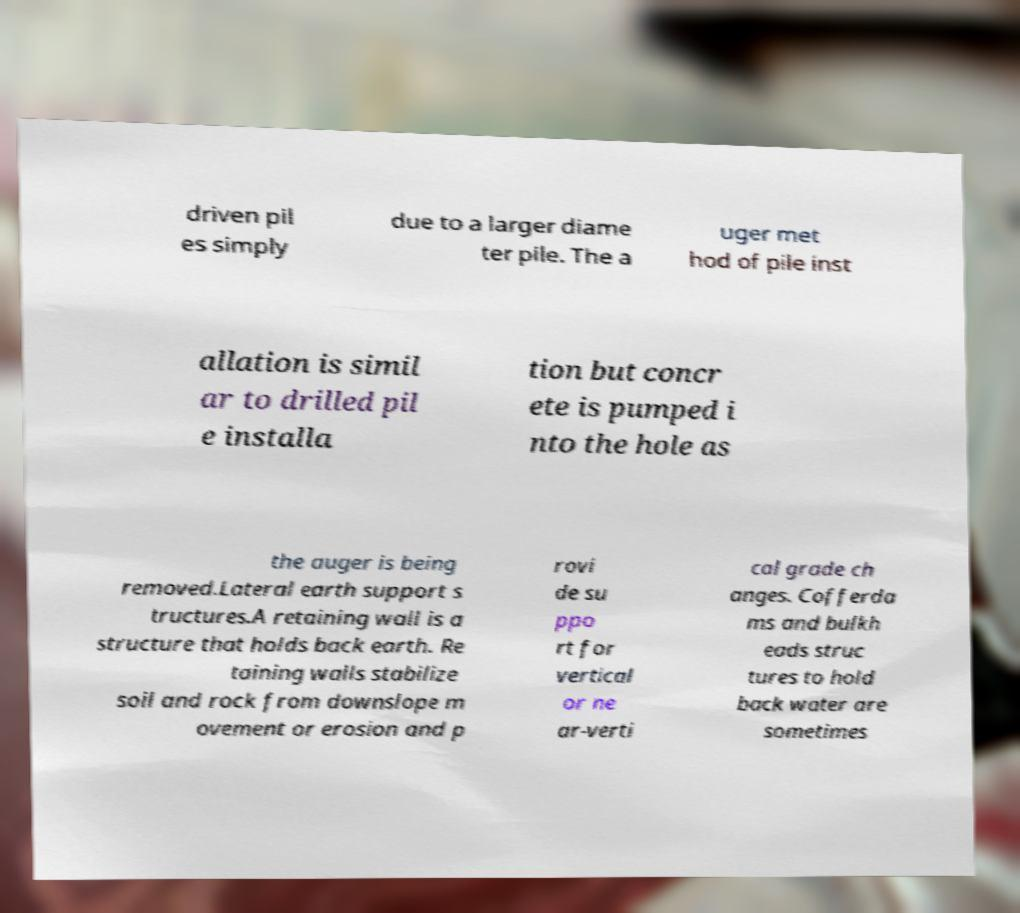What messages or text are displayed in this image? I need them in a readable, typed format. driven pil es simply due to a larger diame ter pile. The a uger met hod of pile inst allation is simil ar to drilled pil e installa tion but concr ete is pumped i nto the hole as the auger is being removed.Lateral earth support s tructures.A retaining wall is a structure that holds back earth. Re taining walls stabilize soil and rock from downslope m ovement or erosion and p rovi de su ppo rt for vertical or ne ar-verti cal grade ch anges. Cofferda ms and bulkh eads struc tures to hold back water are sometimes 